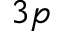<formula> <loc_0><loc_0><loc_500><loc_500>3 p</formula> 